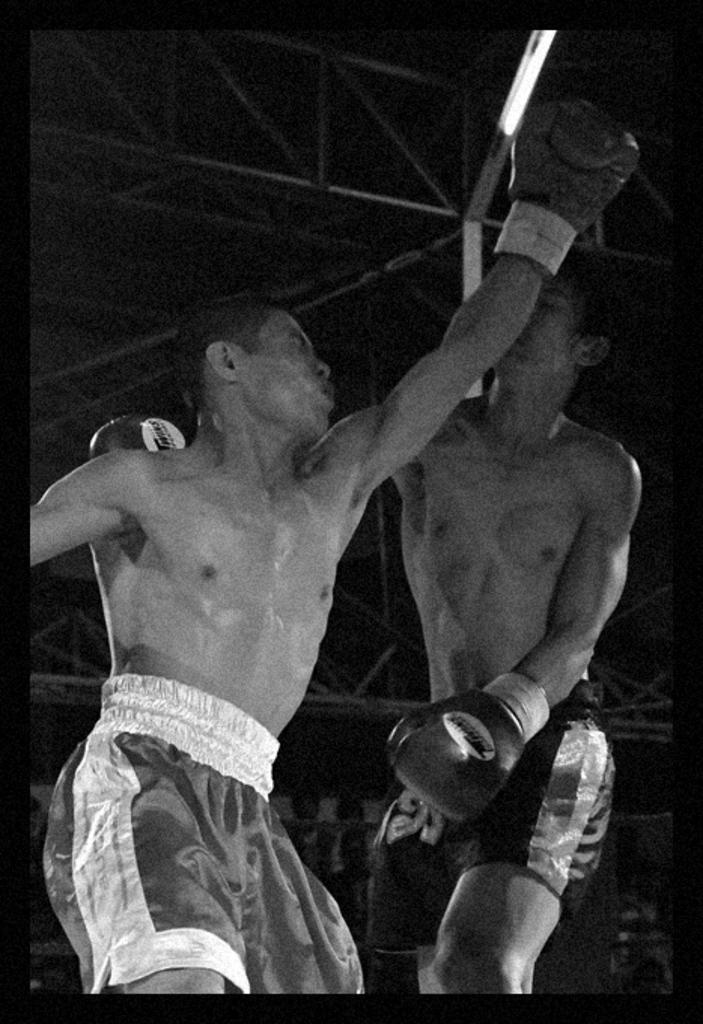What activity are the two people in the image engaged in? The two people in the image are boxing in a ring. What type of gloves are the boxers wearing? The boxers are wearing gloves on their hands. What is the gender of the boxers? The boxers are men. How is the image presented in terms of color? The image is black and white. What type of nail is being used by the boxers in the image? There are no nails present in the image; the boxers are wearing gloves on their hands. How many stitches are visible on the boxers' clothing in the image? There is no mention of stitches on the boxers' clothing in the image, as the focus is on their boxing activity and attire. 